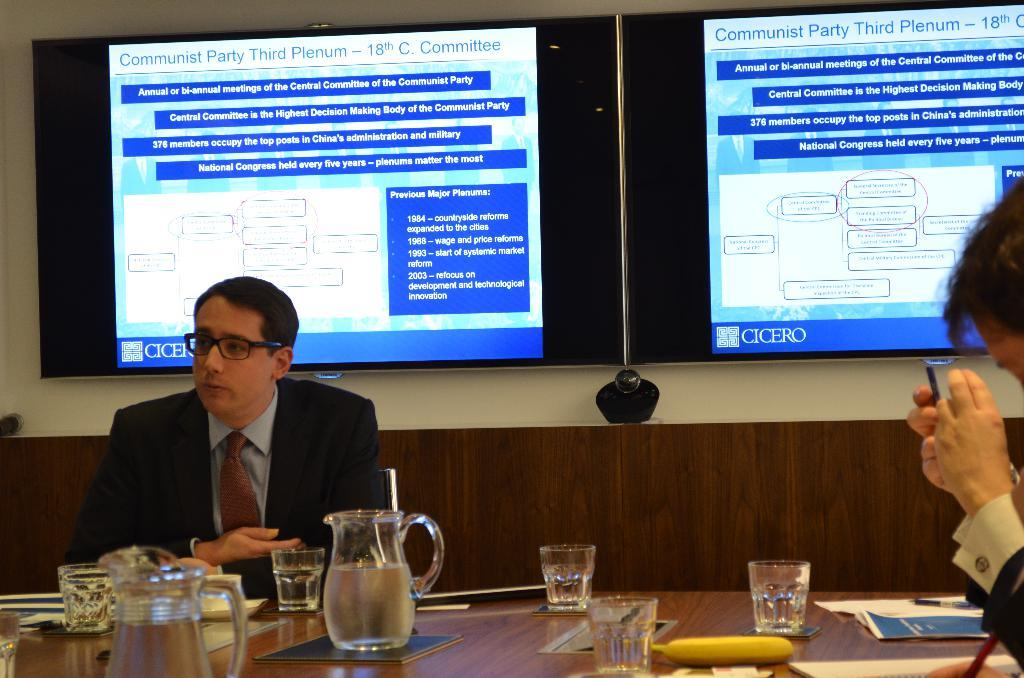<image>
Create a compact narrative representing the image presented. People sitting at a table under a sign that has Communist party displayed. 